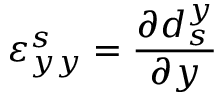<formula> <loc_0><loc_0><loc_500><loc_500>\varepsilon _ { y y } ^ { s } = \frac { \partial d _ { s } ^ { y } } { \partial y }</formula> 